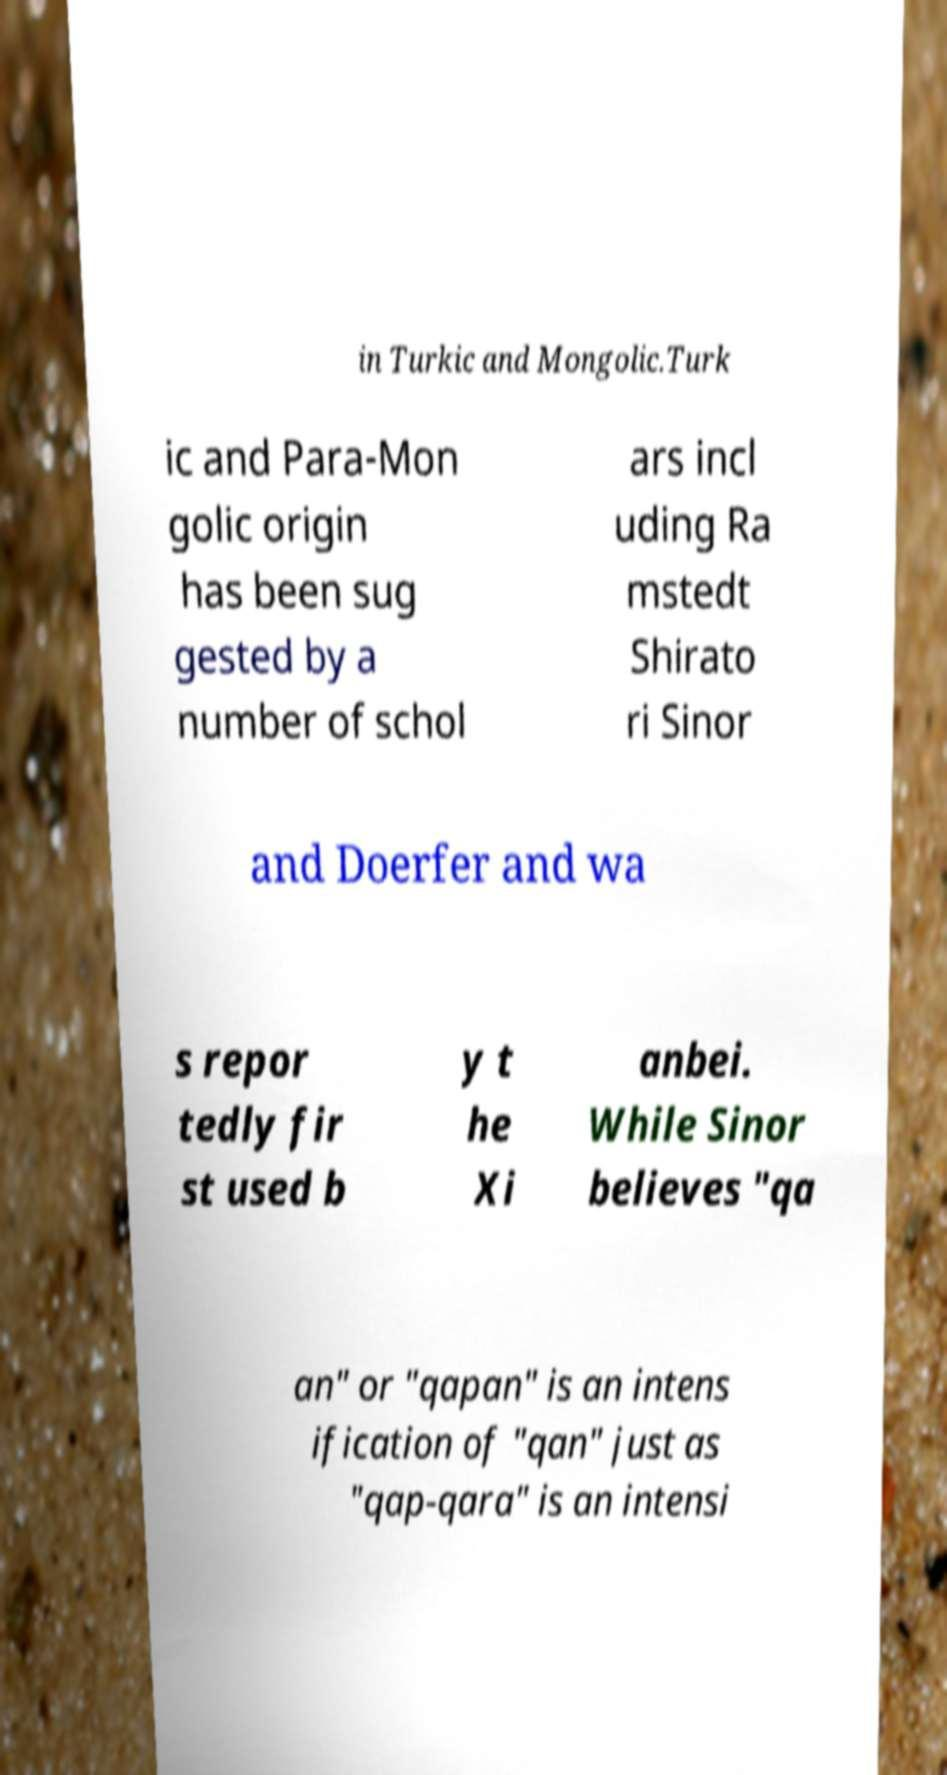Can you accurately transcribe the text from the provided image for me? in Turkic and Mongolic.Turk ic and Para-Mon golic origin has been sug gested by a number of schol ars incl uding Ra mstedt Shirato ri Sinor and Doerfer and wa s repor tedly fir st used b y t he Xi anbei. While Sinor believes "qa an" or "qapan" is an intens ification of "qan" just as "qap-qara" is an intensi 